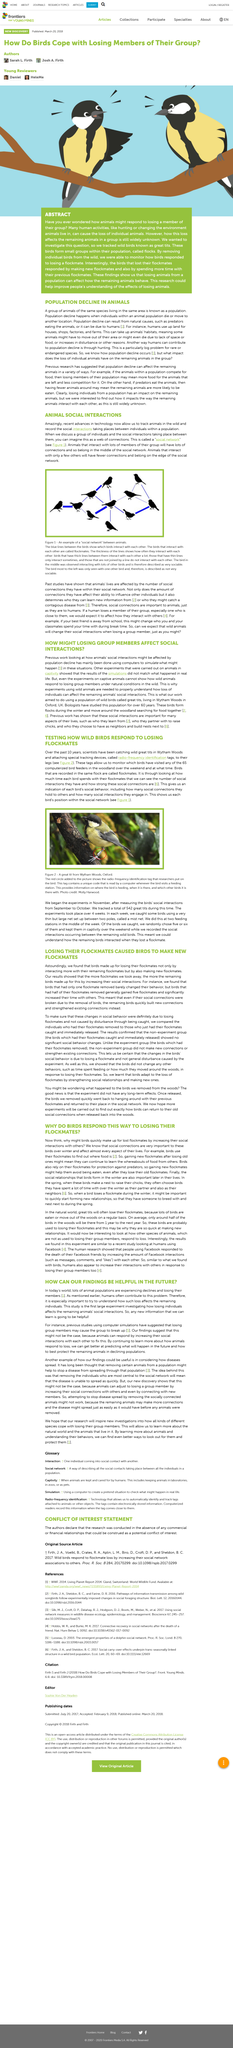Outline some significant characteristics in this image. The experiments commenced in the month of November during the year. After losing flockmates, birds increase their social interactions with other birds in order to locate food sources. Birds that belong to the same flock are referred to as "flockmates. Social networks are intricate webs of connections that link individuals together through various forms of communication and interaction. Birds make nests in the spring to raise their chicks. 